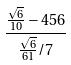<formula> <loc_0><loc_0><loc_500><loc_500>\frac { \frac { \sqrt { 6 } } { 1 0 } - 4 5 6 } { \frac { \sqrt { 6 } } { 6 1 } / 7 }</formula> 